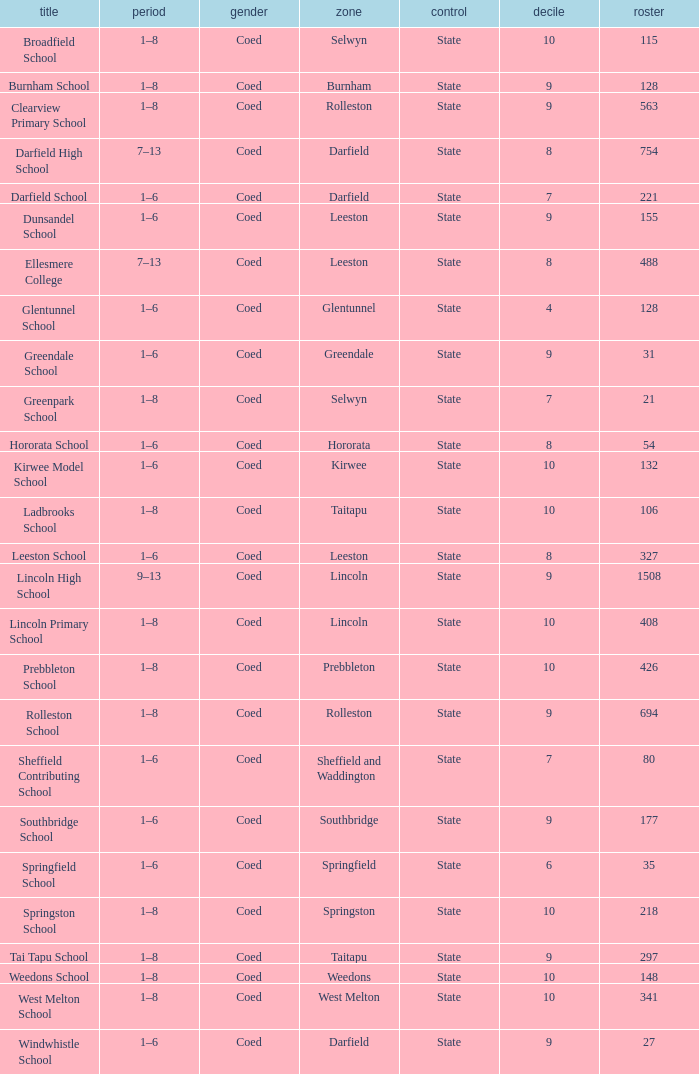Which name has a Roll larger than 297, and Years of 7–13? Darfield High School, Ellesmere College. 